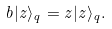<formula> <loc_0><loc_0><loc_500><loc_500>b | z \rangle _ { q } = z | z \rangle _ { q } .</formula> 